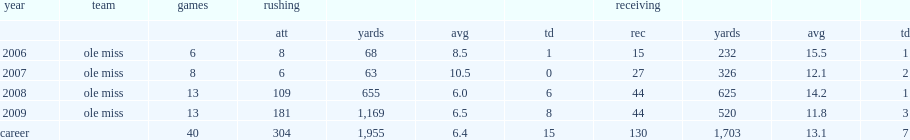How many rushing yards did dexter mccluster get in 2008? 655.0. 